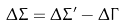Convert formula to latex. <formula><loc_0><loc_0><loc_500><loc_500>\Delta \Sigma = \Delta \Sigma ^ { \prime } - \Delta \Gamma</formula> 